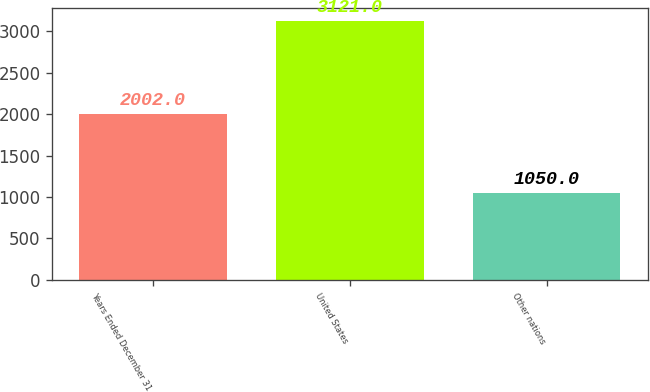<chart> <loc_0><loc_0><loc_500><loc_500><bar_chart><fcel>Years Ended December 31<fcel>United States<fcel>Other nations<nl><fcel>2002<fcel>3121<fcel>1050<nl></chart> 